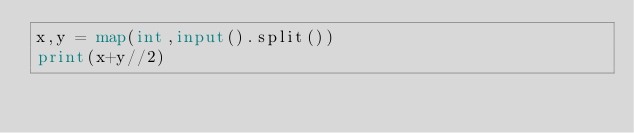Convert code to text. <code><loc_0><loc_0><loc_500><loc_500><_Python_>x,y = map(int,input().split())
print(x+y//2)
</code> 